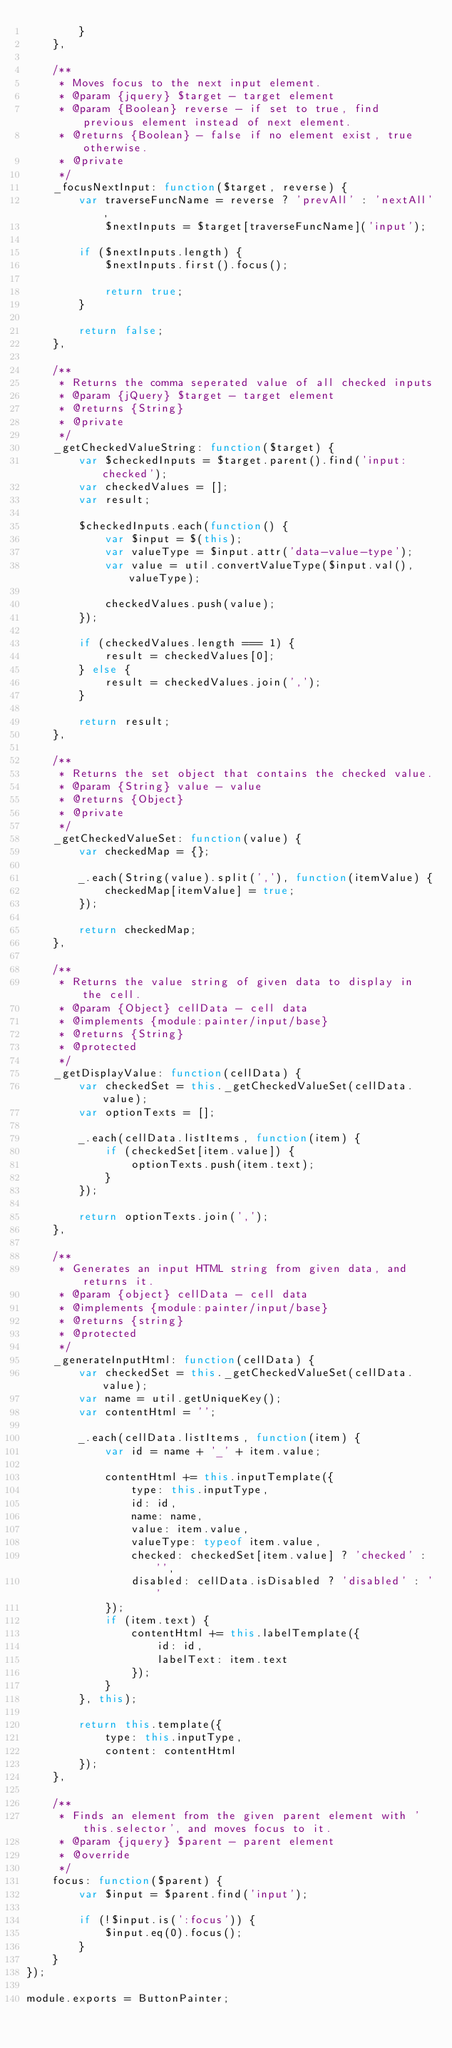Convert code to text. <code><loc_0><loc_0><loc_500><loc_500><_JavaScript_>        }
    },

    /**
     * Moves focus to the next input element.
     * @param {jquery} $target - target element
     * @param {Boolean} reverse - if set to true, find previous element instead of next element.
     * @returns {Boolean} - false if no element exist, true otherwise.
     * @private
     */
    _focusNextInput: function($target, reverse) {
        var traverseFuncName = reverse ? 'prevAll' : 'nextAll',
            $nextInputs = $target[traverseFuncName]('input');

        if ($nextInputs.length) {
            $nextInputs.first().focus();

            return true;
        }

        return false;
    },

    /**
     * Returns the comma seperated value of all checked inputs
     * @param {jQuery} $target - target element
     * @returns {String}
     * @private
     */
    _getCheckedValueString: function($target) {
        var $checkedInputs = $target.parent().find('input:checked');
        var checkedValues = [];
        var result;

        $checkedInputs.each(function() {
            var $input = $(this);
            var valueType = $input.attr('data-value-type');
            var value = util.convertValueType($input.val(), valueType);

            checkedValues.push(value);
        });

        if (checkedValues.length === 1) {
            result = checkedValues[0];
        } else {
            result = checkedValues.join(',');
        }

        return result;
    },

    /**
     * Returns the set object that contains the checked value.
     * @param {String} value - value
     * @returns {Object}
     * @private
     */
    _getCheckedValueSet: function(value) {
        var checkedMap = {};

        _.each(String(value).split(','), function(itemValue) {
            checkedMap[itemValue] = true;
        });

        return checkedMap;
    },

    /**
     * Returns the value string of given data to display in the cell.
     * @param {Object} cellData - cell data
     * @implements {module:painter/input/base}
     * @returns {String}
     * @protected
     */
    _getDisplayValue: function(cellData) {
        var checkedSet = this._getCheckedValueSet(cellData.value);
        var optionTexts = [];

        _.each(cellData.listItems, function(item) {
            if (checkedSet[item.value]) {
                optionTexts.push(item.text);
            }
        });

        return optionTexts.join(',');
    },

    /**
     * Generates an input HTML string from given data, and returns it.
     * @param {object} cellData - cell data
     * @implements {module:painter/input/base}
     * @returns {string}
     * @protected
     */
    _generateInputHtml: function(cellData) {
        var checkedSet = this._getCheckedValueSet(cellData.value);
        var name = util.getUniqueKey();
        var contentHtml = '';

        _.each(cellData.listItems, function(item) {
            var id = name + '_' + item.value;

            contentHtml += this.inputTemplate({
                type: this.inputType,
                id: id,
                name: name,
                value: item.value,
                valueType: typeof item.value,
                checked: checkedSet[item.value] ? 'checked' : '',
                disabled: cellData.isDisabled ? 'disabled' : ''
            });
            if (item.text) {
                contentHtml += this.labelTemplate({
                    id: id,
                    labelText: item.text
                });
            }
        }, this);

        return this.template({
            type: this.inputType,
            content: contentHtml
        });
    },

    /**
     * Finds an element from the given parent element with 'this.selector', and moves focus to it.
     * @param {jquery} $parent - parent element
     * @override
     */
    focus: function($parent) {
        var $input = $parent.find('input');

        if (!$input.is(':focus')) {
            $input.eq(0).focus();
        }
    }
});

module.exports = ButtonPainter;
</code> 